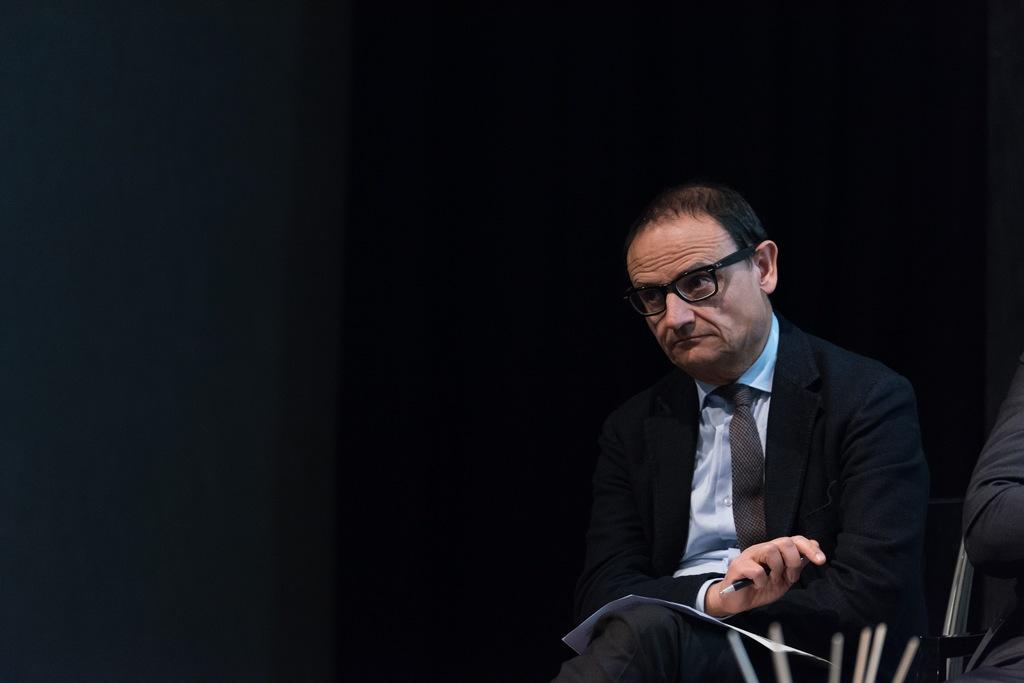Who is present in the image? There is a man in the image. What is the man doing in the image? The man is sitting on a chair. Where is the chair located in the image? The chair is on the right side of the image. What accessories is the man wearing in the image? The man is wearing spectacles and a coat. What can be observed about the lighting in the image? The background of the image is dark. Can you see any marbles on the floor in the image? There are no marbles visible on the floor in the image. Is there a lake in the background of the image? There is no lake present in the image; the background is dark. 